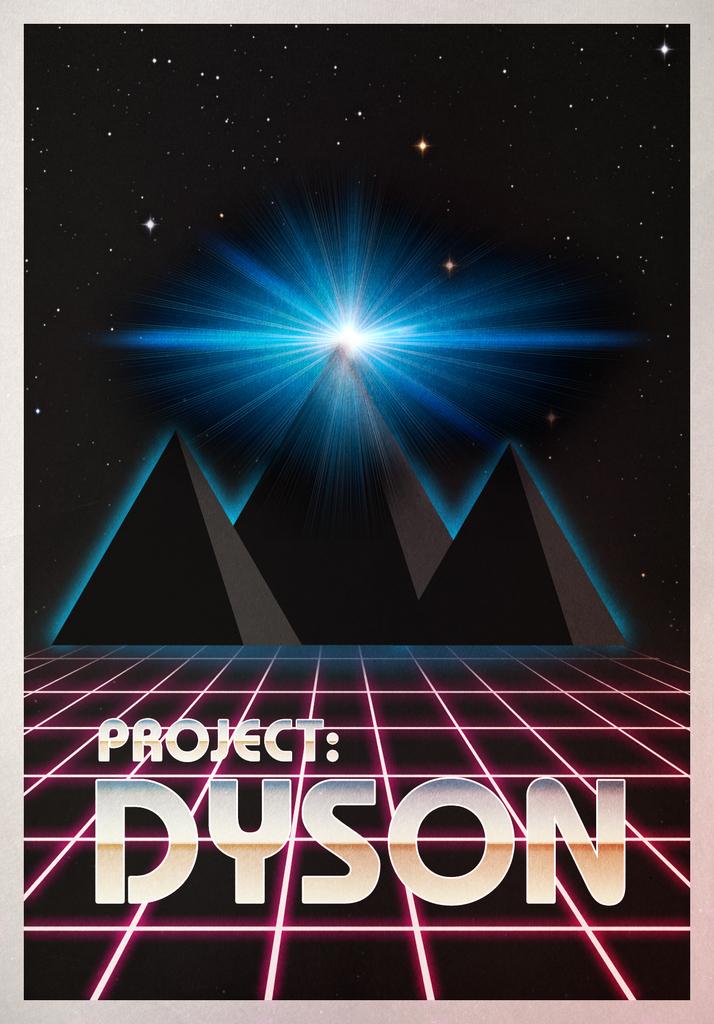What is the name of the project?
Give a very brief answer. Dyson. 